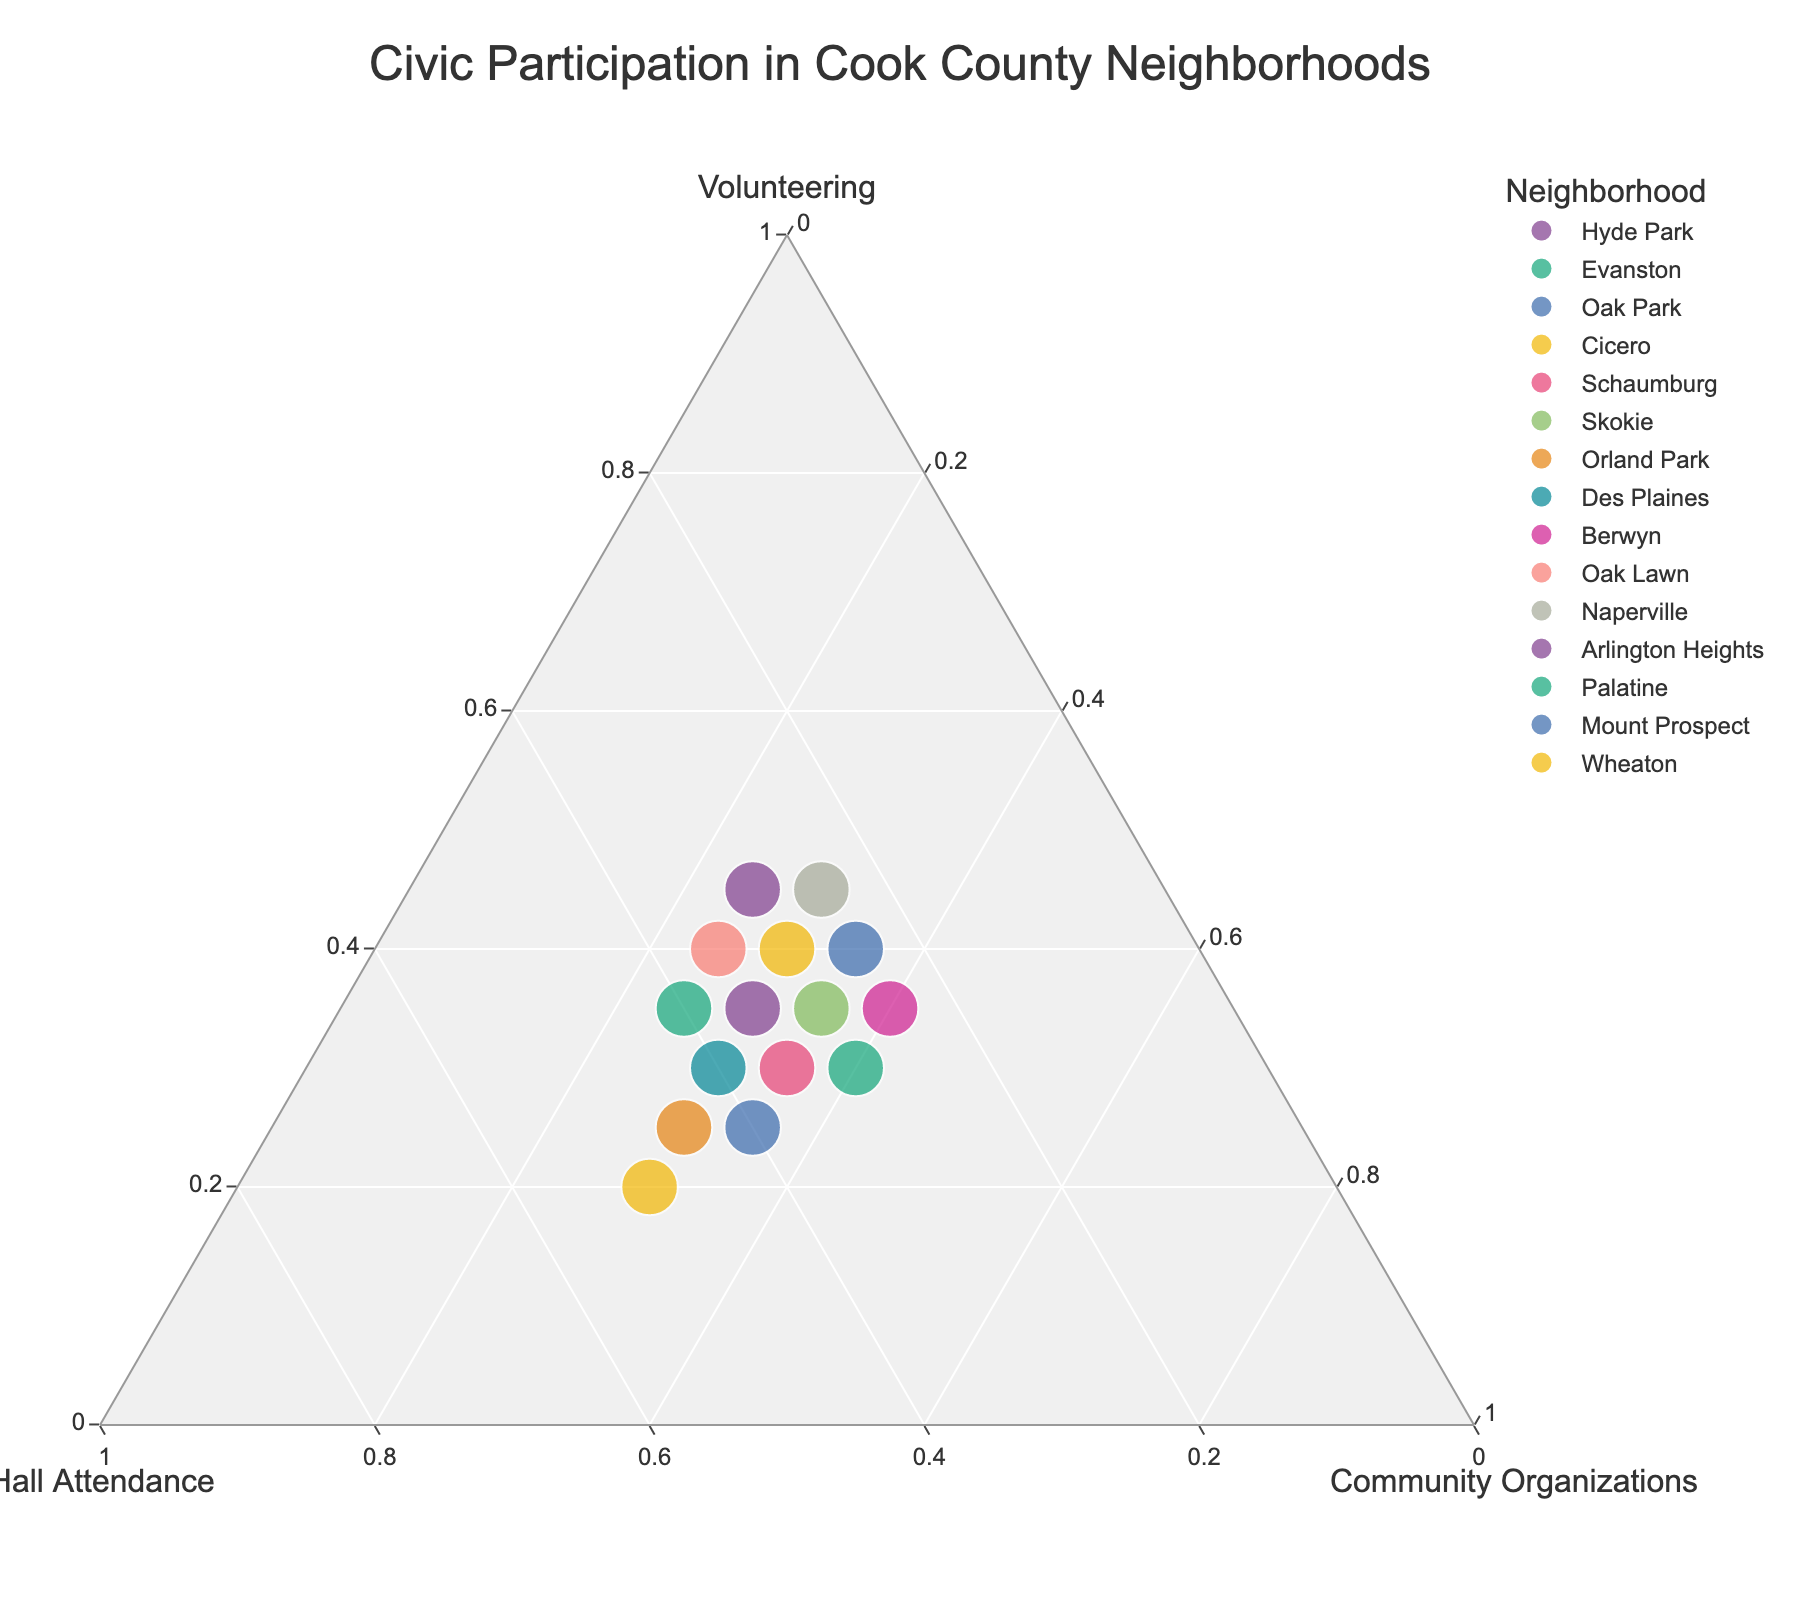What is the title of the figure? The title is typically found at the top of the figure in a larger font size compared to the rest of the text. In this case, the title of the ternary plot is "Civic Participation in Cook County Neighborhoods."
Answer: Civic Participation in Cook County Neighborhoods Which neighborhood has the highest percentage of town hall attendance? To determine this, we need to locate the neighborhood with the highest value on the "Town Hall Attendance" axis of the ternary plot. The town hall attendance rate is represented along one of the axes in the ternary plot, and the neighborhood with the highest value on this axis is Cicero, where Town Hall Attendance is 50%.
Answer: Cicero How many neighborhoods have volunteering rates equal to or greater than 40%? To find this, we look at the ternary plot for points along the "Volunteering" axis. The neighborhoods that surpass or meet the 40% threshold are Hyde Park, Oak Park, Oak Lawn, Naperville, and Wheaton, giving us a total of five neighborhoods.
Answer: 5 Which neighborhoods have an equal percentage of community organization involvement? By examining the "Community Organizations" axis, we identify that Oak Park, Schaumburg, Skokie, Cicero, Des Plaines, Orland Park, Naperville, and Arlington Heights all have community organization involvement rates of either 30% or 35%.
Answer: Oak Park, Schaumburg, Skokie, Cicero, Des Plaines, Orland Park, Naperville, Arlington Heights Which neighborhood allocates the least percentage to volunteering? The neighborhood with the smallest value on the "Volunteering" axis can be identified as Cicero, where Volunteering is 20%.
Answer: Cicero Between Evanston and Palatine, which neighborhood shows a higher engagement in town hall attendance? Both neighborhoods' positions on the "Town Hall Attendance" axis need to be compared. Evanston has a town hall attendance rate of 40%, while Palatine has 30%, making Evanston's attendance higher.
Answer: Evanston Identify the neighborhood with the most balanced participation across all three civic activities. Neighborhoods circa the center of the ternary plot generally represent equal distribution between the three activities. Schaumburg, which has close to equal percentages for Volunteering, Town Hall Attendance, and Community Organizations, is most balanced with 30%, 35%, and 35% respectively.
Answer: Schaumburg Compare the town hall attendance and community organization involvement rates in Orland Park with Mount Prospect. We need to contrast two sets of values: For Orland Park, town hall attendance is 45% and community organization involvement is 30%. For Mount Prospect, town hall attendance is 40% and community engagement is 35%. Orland Park has a higher town hall attendance but lower community organization involvement when compared to Mount Prospect.
Answer: Orland Park: THA >, CO <; Mount Prospect: THA <, CO > What neighborhood is closest in volunteering rates to Skokie but differs in town hall attendance? Skokie has a volunteering rate of 35%. Looking for similar values, Evanston and Berwyn both also have 35% volunteering, but Evanston has higher town hall attendance (40% vs Skokie's 30%), whereas Berwyn has 25%. Comparing both, Evanston meets the criteria and differs in town hall attendance more significantly.
Answer: Evanston Which neighborhood has the closest overall civic engagement profile to Arlington Heights? The ternary plot's objective here is to determine which point is closest to Arlington Heights considering all three axes. Schaumburg, which has 30% (V), 35% (THA), and 35% (CO) is closest to Arlington Heights' 35%, 35%, and 30%, given all proportions are fairly similar.
Answer: Schaumburg 